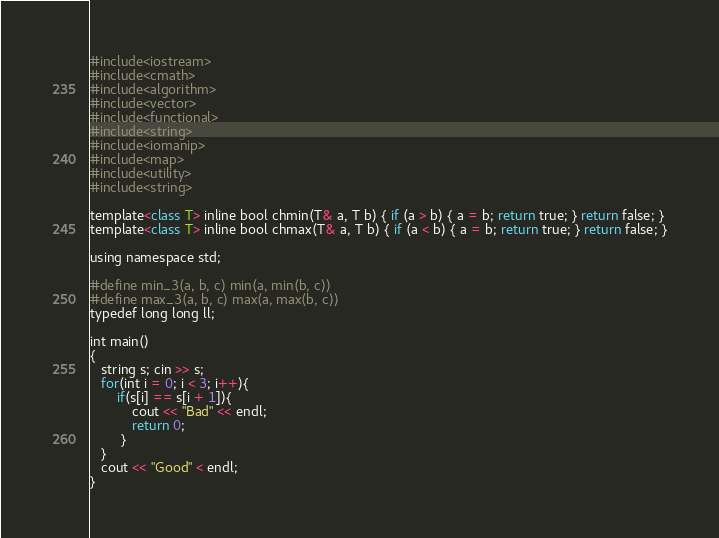<code> <loc_0><loc_0><loc_500><loc_500><_Python_>#include<iostream>
#include<cmath>
#include<algorithm>
#include<vector>
#include<functional>
#include<string>
#include<iomanip>
#include<map>
#include<utility>
#include<string>

template<class T> inline bool chmin(T& a, T b) { if (a > b) { a = b; return true; } return false; }
template<class T> inline bool chmax(T& a, T b) { if (a < b) { a = b; return true; } return false; }

using namespace std;

#define min_3(a, b, c) min(a, min(b, c))
#define max_3(a, b, c) max(a, max(b, c))
typedef long long ll;

int main()
{
   string s; cin >> s;
   for(int i = 0; i < 3; i++){
       if(s[i] == s[i + 1]){
           cout << "Bad" << endl;
           return 0;
        }
   }
   cout << "Good" < endl;
}
</code> 